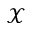Convert formula to latex. <formula><loc_0><loc_0><loc_500><loc_500>\mathcal { X }</formula> 